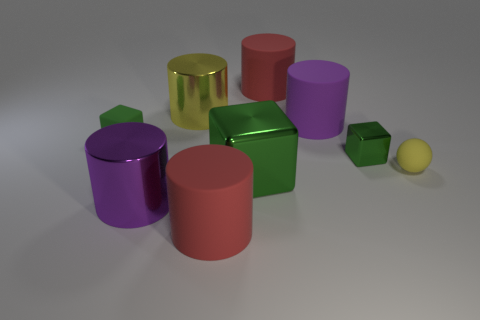Subtract 3 cylinders. How many cylinders are left? 2 Subtract all yellow metal cylinders. How many cylinders are left? 4 Subtract all yellow cylinders. How many cylinders are left? 4 Subtract all blue cylinders. Subtract all green balls. How many cylinders are left? 5 Subtract all blocks. How many objects are left? 6 Subtract all red objects. Subtract all purple matte objects. How many objects are left? 6 Add 3 big purple shiny things. How many big purple shiny things are left? 4 Add 7 rubber cubes. How many rubber cubes exist? 8 Subtract 0 red balls. How many objects are left? 9 